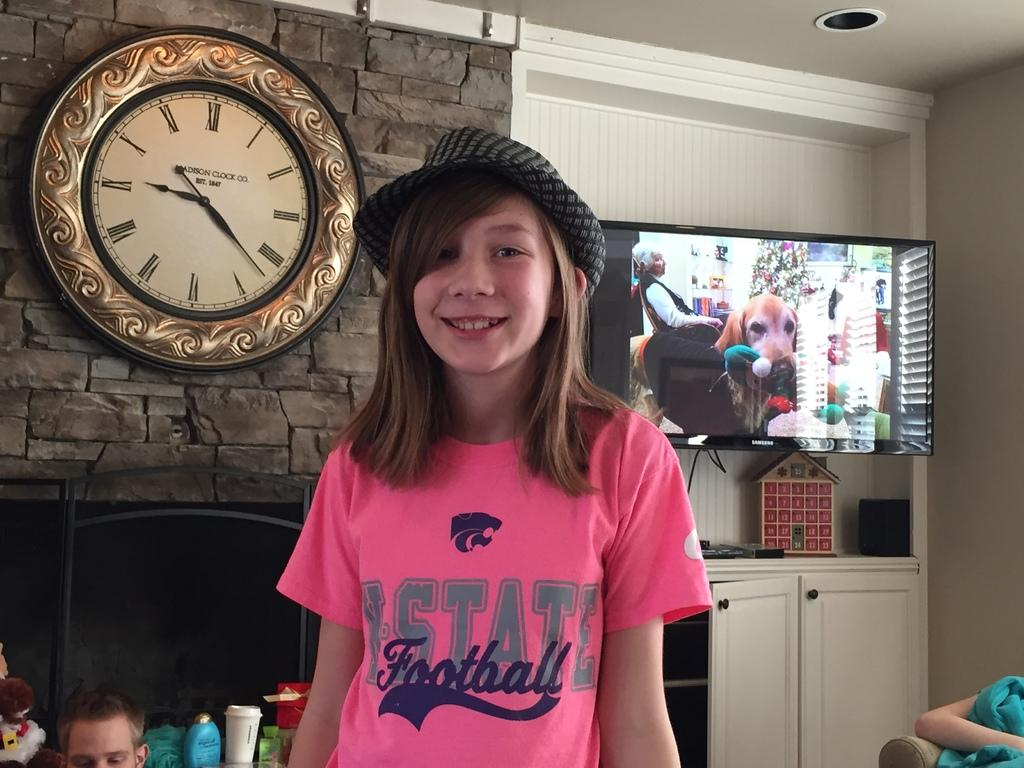<image>
Provide a brief description of the given image. A young girl wearing a pink football shirt is standing in front of a clock. 